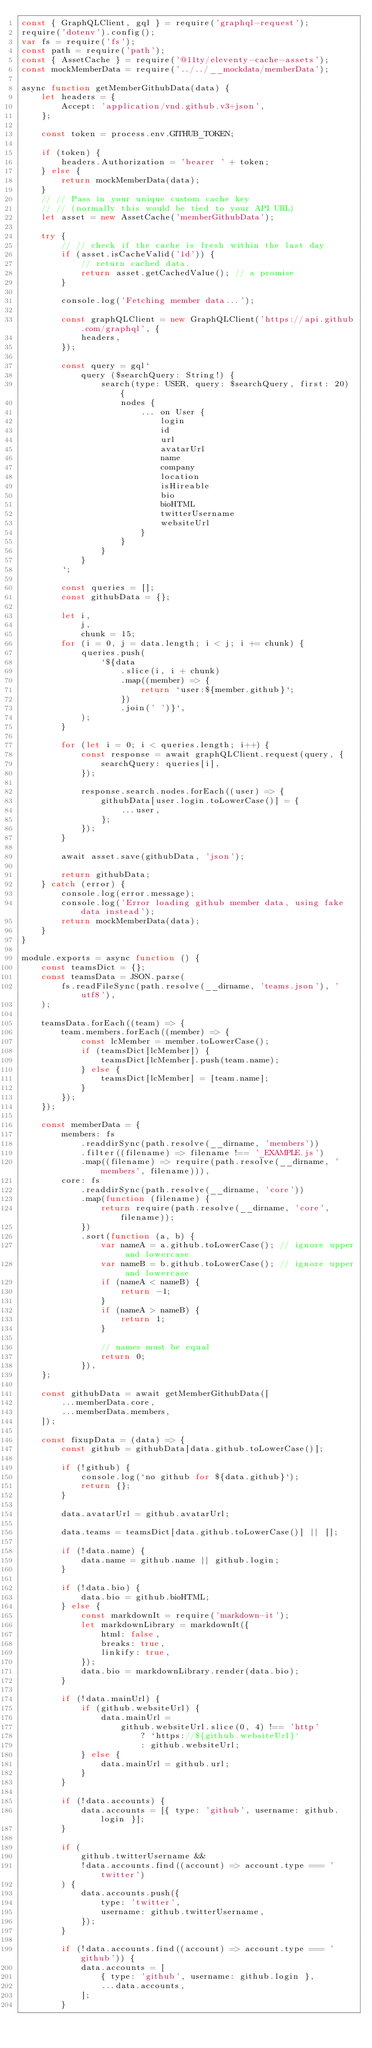<code> <loc_0><loc_0><loc_500><loc_500><_JavaScript_>const { GraphQLClient, gql } = require('graphql-request');
require('dotenv').config();
var fs = require('fs');
const path = require('path');
const { AssetCache } = require('@11ty/eleventy-cache-assets');
const mockMemberData = require('../../__mockdata/memberData');

async function getMemberGithubData(data) {
	let headers = {
		Accept: 'application/vnd.github.v3+json',
	};

	const token = process.env.GITHUB_TOKEN;

	if (token) {
		headers.Authorization = 'bearer ' + token;
	} else {
		return mockMemberData(data);
	}
	// // Pass in your unique custom cache key
	// // (normally this would be tied to your API URL)
	let asset = new AssetCache('memberGithubData');

	try {
		// // check if the cache is fresh within the last day
		if (asset.isCacheValid('1d')) {
			// return cached data.
			return asset.getCachedValue(); // a promise
		}

		console.log('Fetching member data...');

		const graphQLClient = new GraphQLClient('https://api.github.com/graphql', {
			headers,
		});

		const query = gql`
			query ($searchQuery: String!) {
				search(type: USER, query: $searchQuery, first: 20) {
					nodes {
						... on User {
							login
							id
							url
							avatarUrl
							name
							company
							location
							isHireable
							bio
							bioHTML
							twitterUsername
							websiteUrl
						}
					}
				}
			}
		`;

		const queries = [];
		const githubData = {};

		let i,
			j,
			chunk = 15;
		for (i = 0, j = data.length; i < j; i += chunk) {
			queries.push(
				`${data
					.slice(i, i + chunk)
					.map((member) => {
						return `user:${member.github}`;
					})
					.join(' ')}`,
			);
		}

		for (let i = 0; i < queries.length; i++) {
			const response = await graphQLClient.request(query, {
				searchQuery: queries[i],
			});

			response.search.nodes.forEach((user) => {
				githubData[user.login.toLowerCase()] = {
					...user,
				};
			});
		}

		await asset.save(githubData, 'json');

		return githubData;
	} catch (error) {
		console.log(error.message);
		console.log('Error loading github member data, using fake data instead');
		return mockMemberData(data);
	}
}

module.exports = async function () {
	const teamsDict = {};
	const teamsData = JSON.parse(
		fs.readFileSync(path.resolve(__dirname, 'teams.json'), 'utf8'),
	);

	teamsData.forEach((team) => {
		team.members.forEach((member) => {
			const lcMember = member.toLowerCase();
			if (teamsDict[lcMember]) {
				teamsDict[lcMember].push(team.name);
			} else {
				teamsDict[lcMember] = [team.name];
			}
		});
	});

	const memberData = {
		members: fs
			.readdirSync(path.resolve(__dirname, 'members'))
			.filter((filename) => filename !== '_EXAMPLE.js')
			.map((filename) => require(path.resolve(__dirname, 'members', filename))),
		core: fs
			.readdirSync(path.resolve(__dirname, 'core'))
			.map(function (filename) {
				return require(path.resolve(__dirname, 'core', filename));
			})
			.sort(function (a, b) {
				var nameA = a.github.toLowerCase(); // ignore upper and lowercase
				var nameB = b.github.toLowerCase(); // ignore upper and lowercase
				if (nameA < nameB) {
					return -1;
				}
				if (nameA > nameB) {
					return 1;
				}

				// names must be equal
				return 0;
			}),
	};

	const githubData = await getMemberGithubData([
		...memberData.core,
		...memberData.members,
	]);

	const fixupData = (data) => {
		const github = githubData[data.github.toLowerCase()];

		if (!github) {
			console.log(`no github for ${data.github}`);
			return {};
		}

		data.avatarUrl = github.avatarUrl;

		data.teams = teamsDict[data.github.toLowerCase()] || [];

		if (!data.name) {
			data.name = github.name || github.login;
		}

		if (!data.bio) {
			data.bio = github.bioHTML;
		} else {
			const markdownIt = require('markdown-it');
			let markdownLibrary = markdownIt({
				html: false,
				breaks: true,
				linkify: true,
			});
			data.bio = markdownLibrary.render(data.bio);
		}

		if (!data.mainUrl) {
			if (github.websiteUrl) {
				data.mainUrl =
					github.websiteUrl.slice(0, 4) !== 'http'
						? `https://${github.websiteUrl}`
						: github.websiteUrl;
			} else {
				data.mainUrl = github.url;
			}
		}

		if (!data.accounts) {
			data.accounts = [{ type: 'github', username: github.login }];
		}

		if (
			github.twitterUsername &&
			!data.accounts.find((account) => account.type === 'twitter')
		) {
			data.accounts.push({
				type: 'twitter',
				username: github.twitterUsername,
			});
		}

		if (!data.accounts.find((account) => account.type === 'github')) {
			data.accounts = [
				{ type: 'github', username: github.login },
				...data.accounts,
			];
		}
</code> 